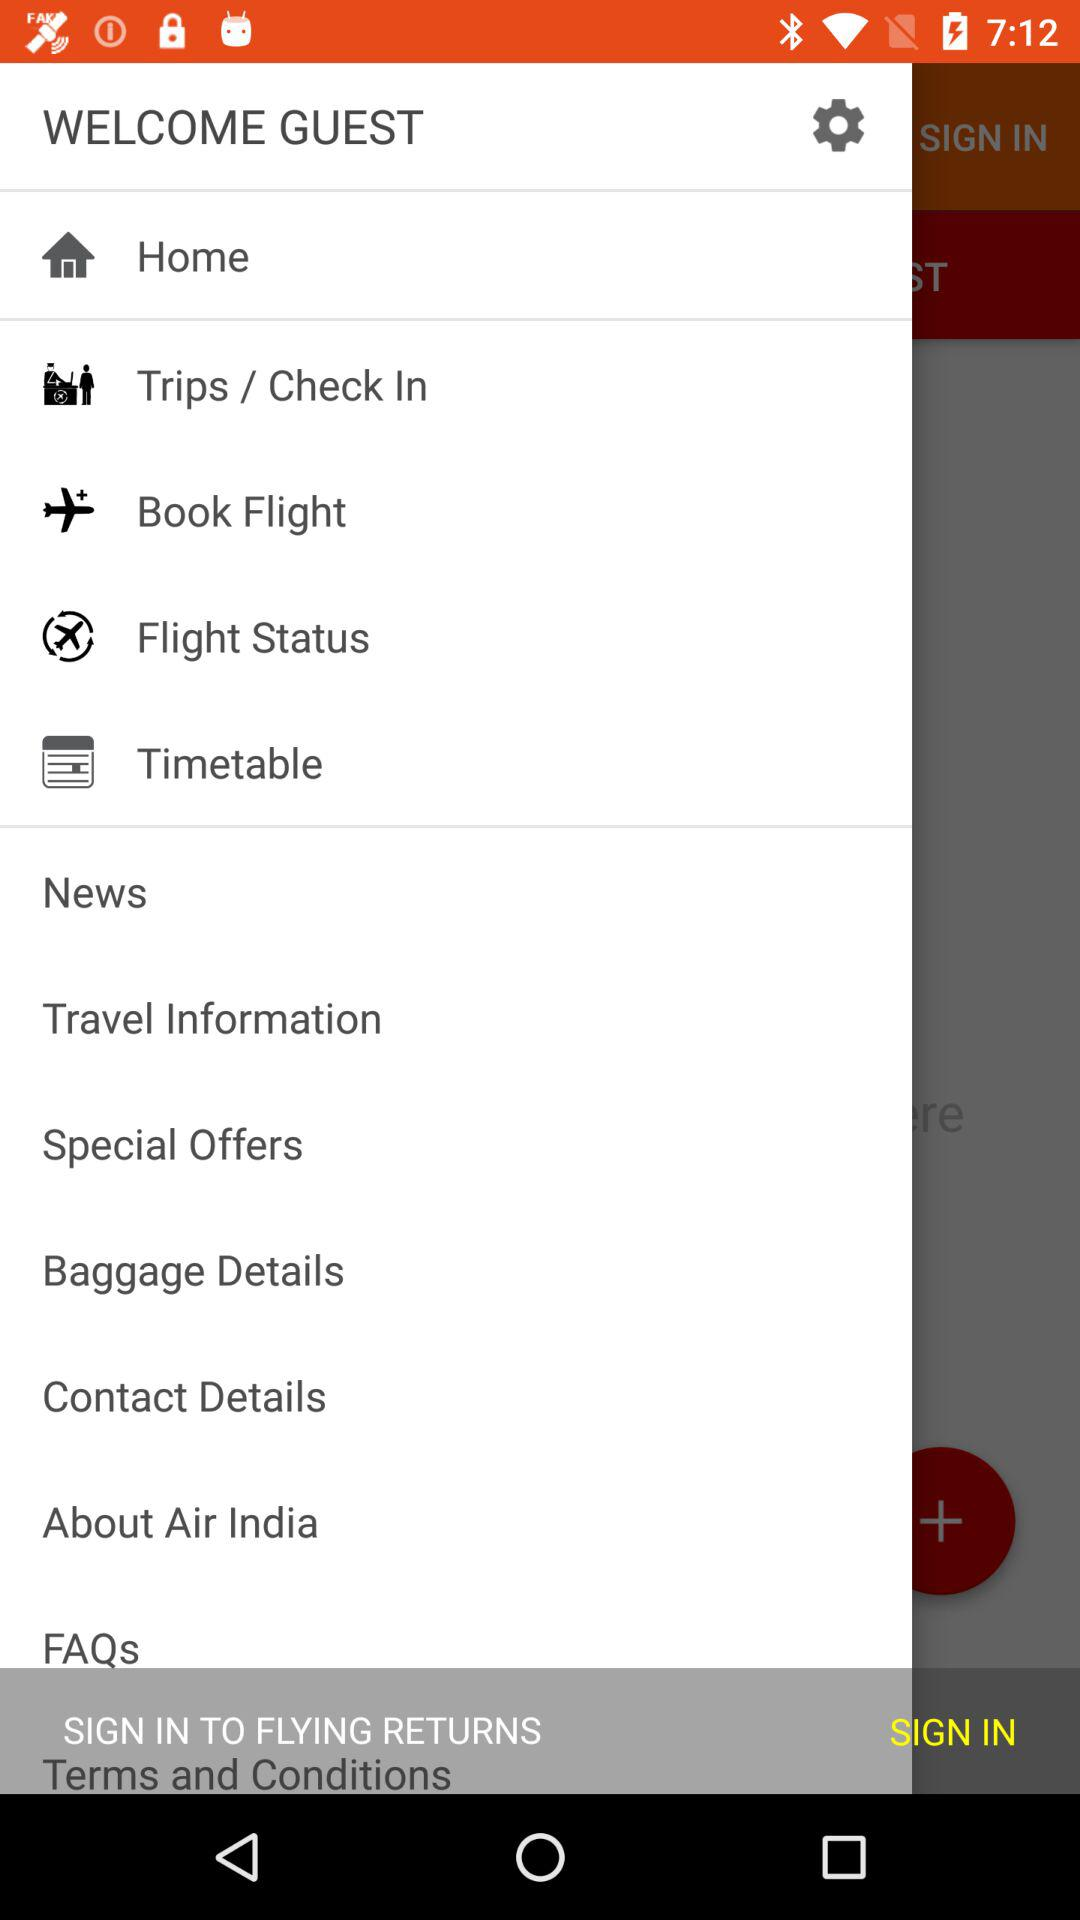What is the application name?
When the provided information is insufficient, respond with <no answer>. <no answer> 